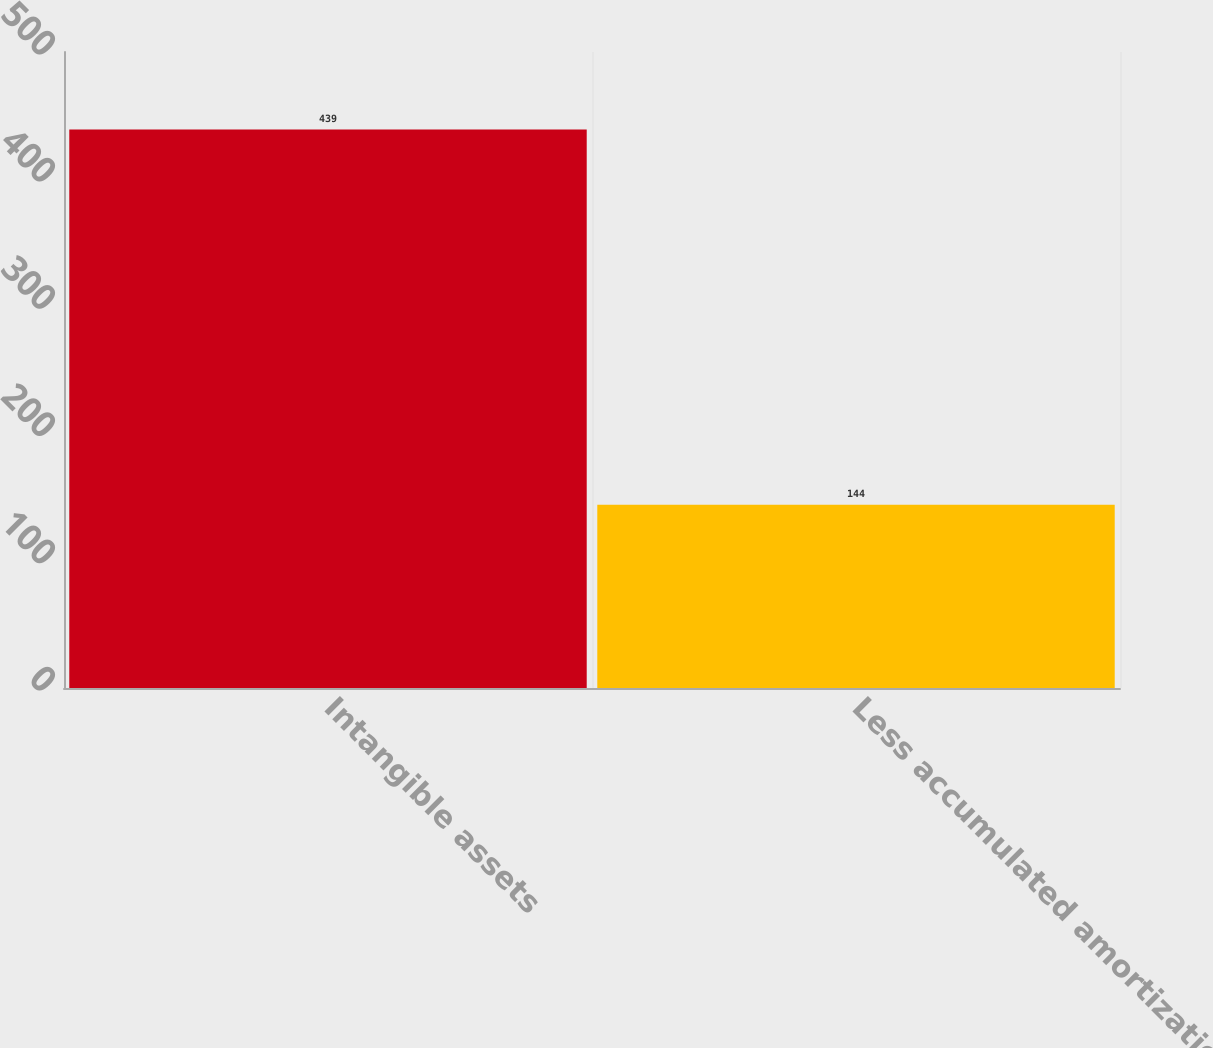Convert chart to OTSL. <chart><loc_0><loc_0><loc_500><loc_500><bar_chart><fcel>Intangible assets<fcel>Less accumulated amortization<nl><fcel>439<fcel>144<nl></chart> 